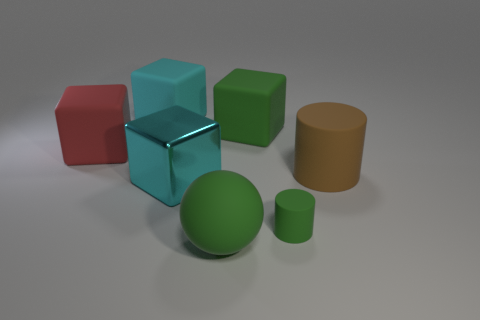Add 2 spheres. How many objects exist? 9 Subtract all spheres. How many objects are left? 6 Subtract all big cyan rubber cubes. Subtract all large brown objects. How many objects are left? 5 Add 4 red matte blocks. How many red matte blocks are left? 5 Add 5 brown cylinders. How many brown cylinders exist? 6 Subtract 0 cyan cylinders. How many objects are left? 7 